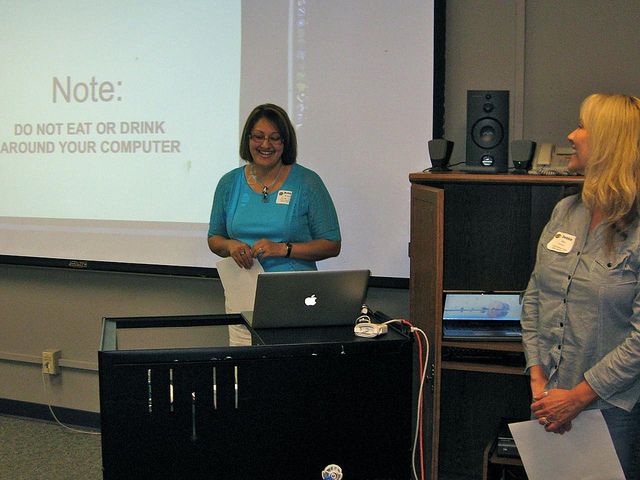Please extract the text content from this image. Note DRINK COMPUTER DO YOUR AROUND OT EAT NOT 